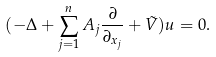<formula> <loc_0><loc_0><loc_500><loc_500>( - \Delta + \sum _ { j = 1 } ^ { n } A _ { j } \frac { \partial } { \partial _ { x _ { j } } } + \tilde { V } ) u = 0 .</formula> 